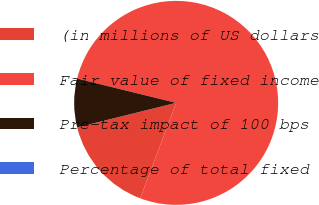<chart> <loc_0><loc_0><loc_500><loc_500><pie_chart><fcel>(in millions of US dollars<fcel>Fair value of fixed income<fcel>Pre-tax impact of 100 bps<fcel>Percentage of total fixed<nl><fcel>15.39%<fcel>76.91%<fcel>7.7%<fcel>0.01%<nl></chart> 